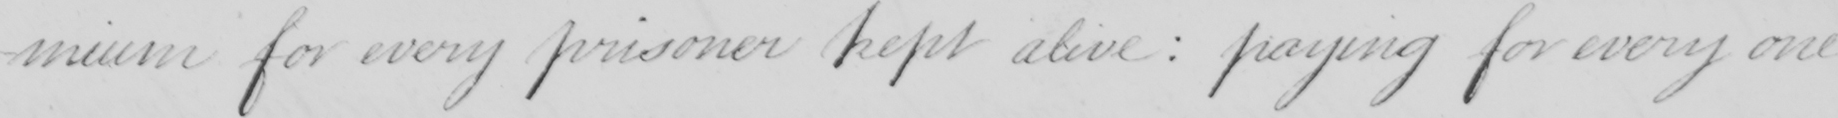What does this handwritten line say? -mium for every prisoner kept alive  :  paying for every one 